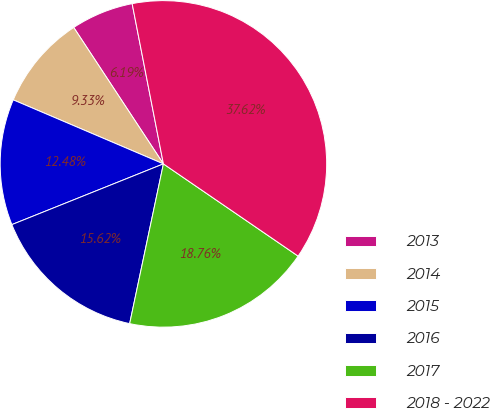Convert chart to OTSL. <chart><loc_0><loc_0><loc_500><loc_500><pie_chart><fcel>2013<fcel>2014<fcel>2015<fcel>2016<fcel>2017<fcel>2018 - 2022<nl><fcel>6.19%<fcel>9.33%<fcel>12.48%<fcel>15.62%<fcel>18.76%<fcel>37.62%<nl></chart> 